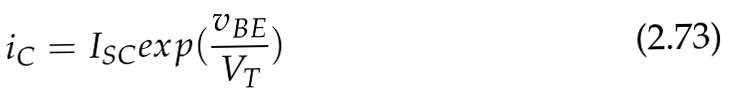Convert formula to latex. <formula><loc_0><loc_0><loc_500><loc_500>i _ { C } = I _ { S C } e x p ( \frac { v _ { B E } } { V _ { T } } )</formula> 